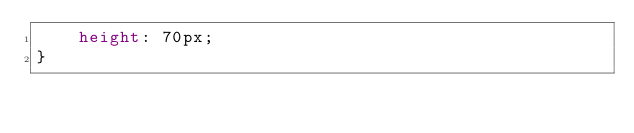Convert code to text. <code><loc_0><loc_0><loc_500><loc_500><_CSS_>    height: 70px;
}</code> 